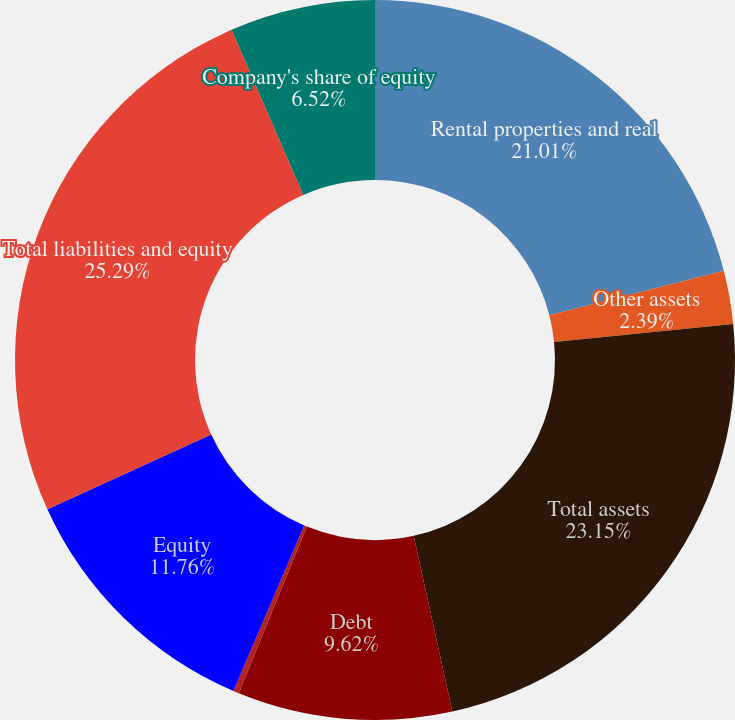Convert chart. <chart><loc_0><loc_0><loc_500><loc_500><pie_chart><fcel>Rental properties and real<fcel>Other assets<fcel>Total assets<fcel>Debt<fcel>Other liabilities<fcel>Equity<fcel>Total liabilities and equity<fcel>Company's share of equity<nl><fcel>21.01%<fcel>2.39%<fcel>23.15%<fcel>9.62%<fcel>0.26%<fcel>11.76%<fcel>25.28%<fcel>6.52%<nl></chart> 